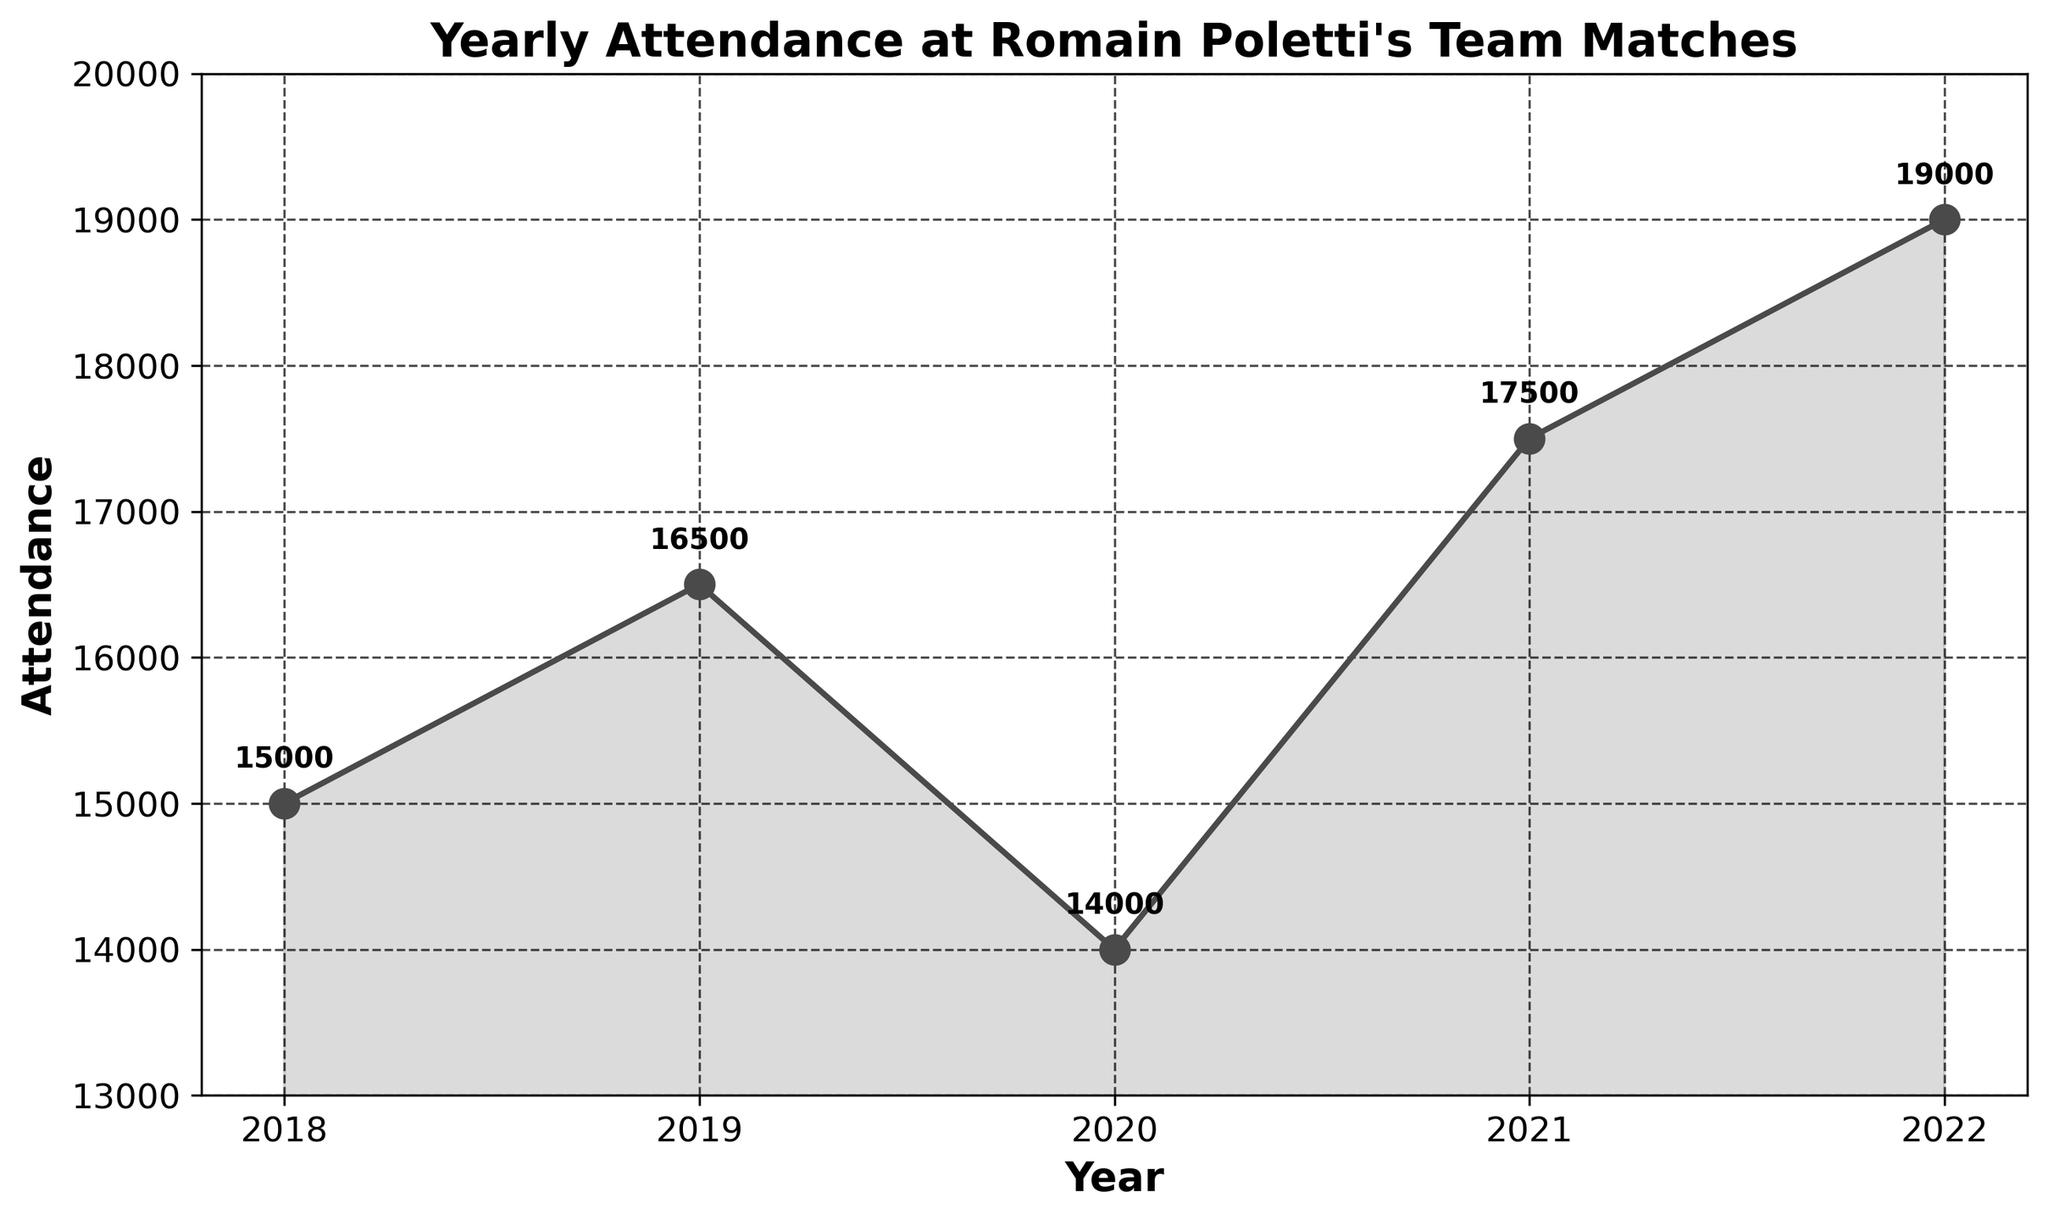What's the title of the figure? The title is usually shown at the top of the figure in a larger and bolder font. The title helps to understand what the plot is about. In this plot, the title is "Yearly Attendance at Romain Poletti's Team Matches".
Answer: Yearly Attendance at Romain Poletti's Team Matches How many years of data are presented in the plot? By counting the number of data points along the x-axis, we can determine the number of years represented. In this plot, the years range from 2018 to 2022.
Answer: 5 What was the attendance in 2020? The point corresponding to the year 2020 on the x-axis is marked. The y-value at this point indicates the attendance. From the plot, the attendance in 2020 is marked as 14,000.
Answer: 14,000 What's the average attendance over the five years? To find the average, sum all the yearly attendance values and then divide by the number of years. The attendance values are 15,000, 16,500, 14,000, 17,500, and 19,000. So, (15000 + 16500 + 14000 + 17500 + 19000) / 5 = 16400.
Answer: 16,400 Which year had the highest attendance? By comparing the y-values of all data points, we notice that the highest point is in the year 2022. The attendance value here is 19,000.
Answer: 2022 What’s the difference in attendance between 2019 and 2020? From the plot, we can see the attendance in 2019 was 16,500 and in 2020 it was 14,000. The difference is calculated by subtracting the 2020 value from the 2019 value: 16,500 - 14,000 = 2,500.
Answer: 2,500 How does the attendance in 2022 compare to 2021? The plot shows the attendance in 2022 as 19,000 and in 2021 as 17,500. 19,000 is greater than 17,500, so the attendance in 2022 is higher than in 2021.
Answer: Higher in 2022 What's the trend of the attendance over the five years shown? Observing the plot, we see an initial increase from 2018 to 2019, a drop in 2020, followed by a steady increase in 2021 and 2022. Hence, the overall trend shows an increase with a dip in 2020.
Answer: Increasing with a dip in 2020 